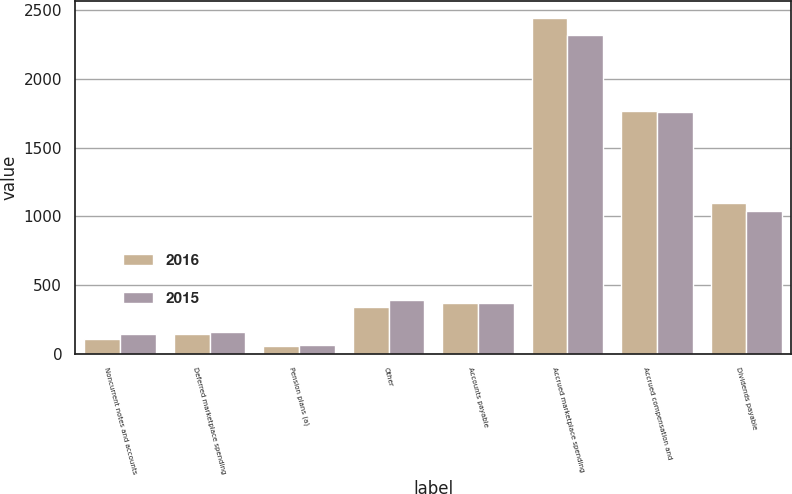<chart> <loc_0><loc_0><loc_500><loc_500><stacked_bar_chart><ecel><fcel>Noncurrent notes and accounts<fcel>Deferred marketplace spending<fcel>Pension plans (a)<fcel>Other<fcel>Accounts payable<fcel>Accrued marketplace spending<fcel>Accrued compensation and<fcel>Dividends payable<nl><fcel>2016<fcel>105<fcel>140<fcel>53<fcel>338<fcel>364.5<fcel>2444<fcel>1770<fcel>1097<nl><fcel>2015<fcel>140<fcel>159<fcel>60<fcel>391<fcel>364.5<fcel>2319<fcel>1759<fcel>1041<nl></chart> 